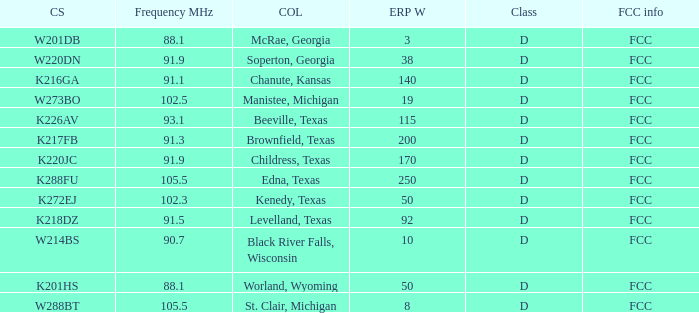I'm looking to parse the entire table for insights. Could you assist me with that? {'header': ['CS', 'Frequency MHz', 'COL', 'ERP W', 'Class', 'FCC info'], 'rows': [['W201DB', '88.1', 'McRae, Georgia', '3', 'D', 'FCC'], ['W220DN', '91.9', 'Soperton, Georgia', '38', 'D', 'FCC'], ['K216GA', '91.1', 'Chanute, Kansas', '140', 'D', 'FCC'], ['W273BO', '102.5', 'Manistee, Michigan', '19', 'D', 'FCC'], ['K226AV', '93.1', 'Beeville, Texas', '115', 'D', 'FCC'], ['K217FB', '91.3', 'Brownfield, Texas', '200', 'D', 'FCC'], ['K220JC', '91.9', 'Childress, Texas', '170', 'D', 'FCC'], ['K288FU', '105.5', 'Edna, Texas', '250', 'D', 'FCC'], ['K272EJ', '102.3', 'Kenedy, Texas', '50', 'D', 'FCC'], ['K218DZ', '91.5', 'Levelland, Texas', '92', 'D', 'FCC'], ['W214BS', '90.7', 'Black River Falls, Wisconsin', '10', 'D', 'FCC'], ['K201HS', '88.1', 'Worland, Wyoming', '50', 'D', 'FCC'], ['W288BT', '105.5', 'St. Clair, Michigan', '8', 'D', 'FCC']]} What is City of License, when Frequency MHz is less than 102.5? McRae, Georgia, Soperton, Georgia, Chanute, Kansas, Beeville, Texas, Brownfield, Texas, Childress, Texas, Kenedy, Texas, Levelland, Texas, Black River Falls, Wisconsin, Worland, Wyoming. 